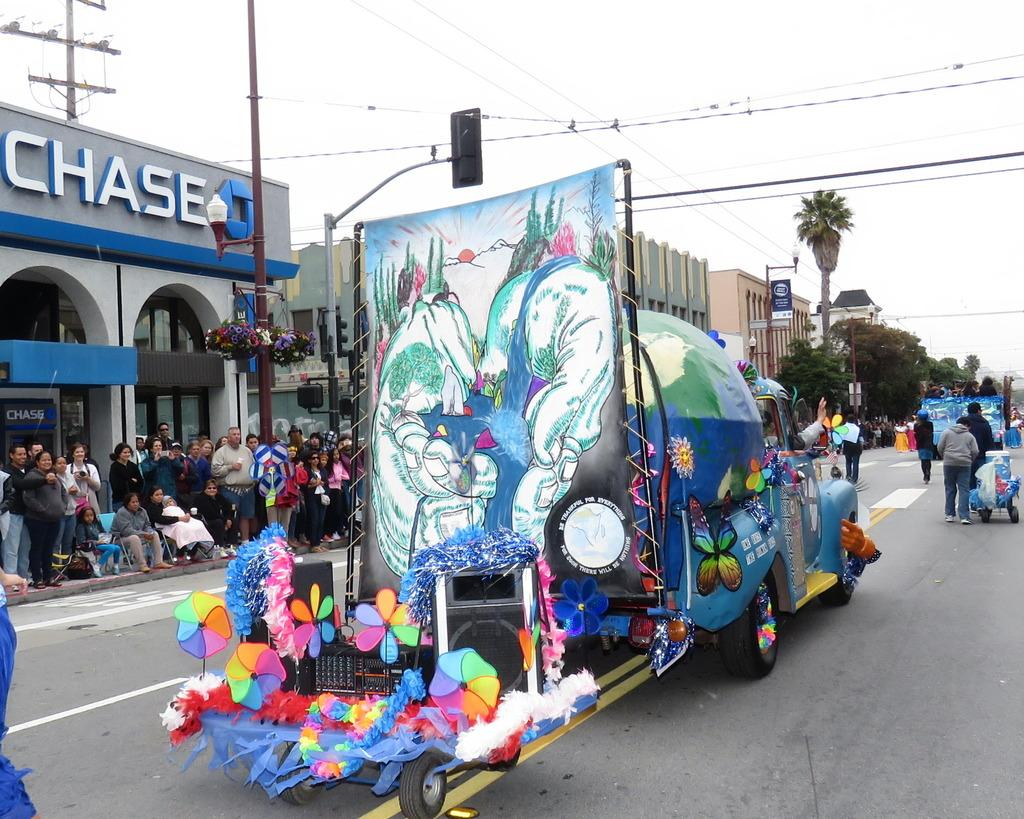<image>
Write a terse but informative summary of the picture. A chase bank is next to a parade float. 